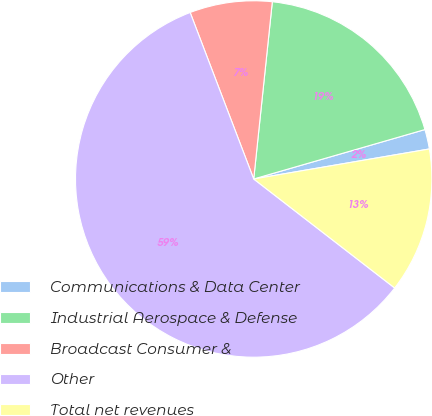<chart> <loc_0><loc_0><loc_500><loc_500><pie_chart><fcel>Communications & Data Center<fcel>Industrial Aerospace & Defense<fcel>Broadcast Consumer &<fcel>Other<fcel>Total net revenues<nl><fcel>1.78%<fcel>18.86%<fcel>7.47%<fcel>58.72%<fcel>13.17%<nl></chart> 